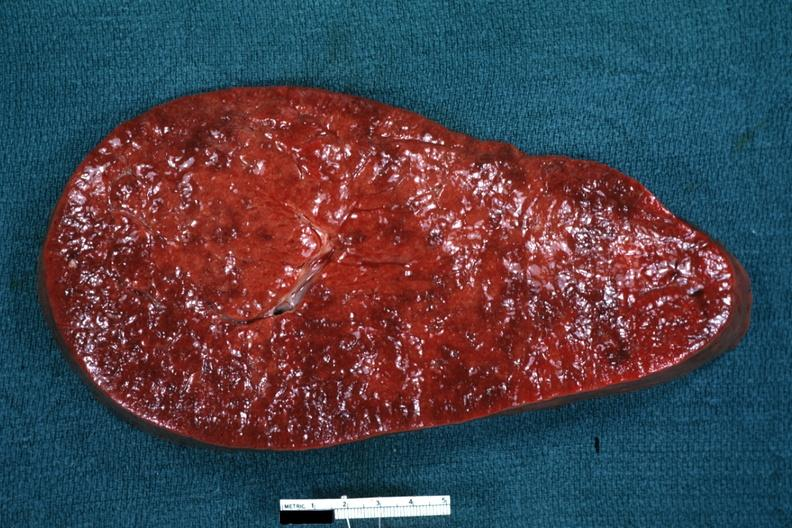does this image show enlarged spleen with rather obvious infiltrate?
Answer the question using a single word or phrase. Yes 